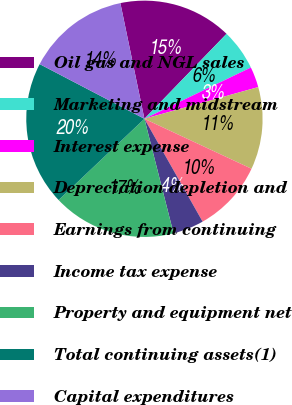Convert chart to OTSL. <chart><loc_0><loc_0><loc_500><loc_500><pie_chart><fcel>Oil gas and NGL sales<fcel>Marketing and midstream<fcel>Interest expense<fcel>Depreciation depletion and<fcel>Earnings from continuing<fcel>Income tax expense<fcel>Property and equipment net<fcel>Total continuing assets(1)<fcel>Capital expenditures<nl><fcel>15.49%<fcel>5.63%<fcel>2.82%<fcel>11.27%<fcel>9.86%<fcel>4.23%<fcel>16.9%<fcel>19.72%<fcel>14.08%<nl></chart> 